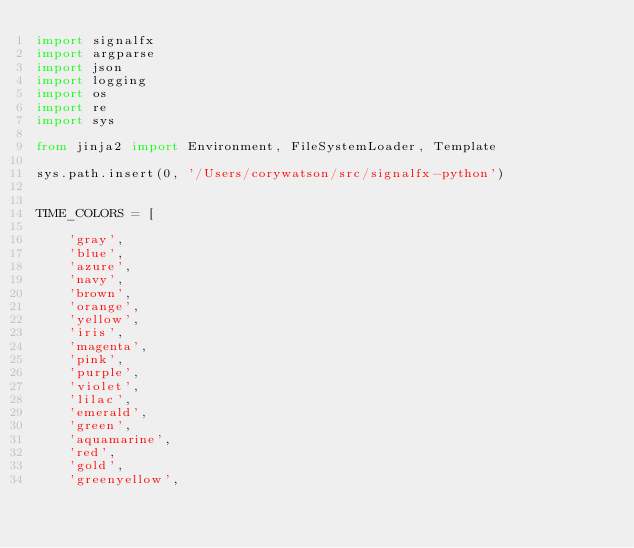<code> <loc_0><loc_0><loc_500><loc_500><_Python_>import signalfx
import argparse
import json
import logging
import os
import re
import sys

from jinja2 import Environment, FileSystemLoader, Template

sys.path.insert(0, '/Users/corywatson/src/signalfx-python')


TIME_COLORS = [

    'gray',
    'blue',
    'azure',
    'navy',
    'brown',
    'orange',
    'yellow',
    'iris',
    'magenta',
    'pink',
    'purple',
    'violet',
    'lilac',
    'emerald',
    'green',
    'aquamarine',
    'red',
    'gold',
    'greenyellow',</code> 